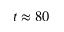Convert formula to latex. <formula><loc_0><loc_0><loc_500><loc_500>t \approx 8 0</formula> 